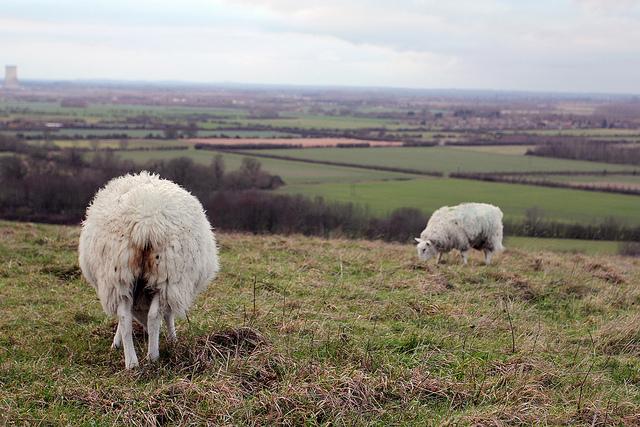How many sheep are there?
Quick response, please. 2. What are the sheep doing?
Keep it brief. Grazing. Has the grass been cut?
Be succinct. No. How many animals are in the picture?
Quick response, please. 2. How many animals do you see?
Keep it brief. 2. Are there any trees?
Keep it brief. Yes. How many sheep are on the grass?
Answer briefly. 2. 